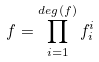<formula> <loc_0><loc_0><loc_500><loc_500>f = \prod _ { i = 1 } ^ { d e g ( f ) } f _ { i } ^ { i }</formula> 